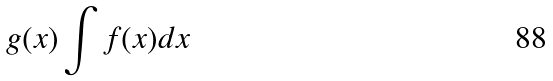Convert formula to latex. <formula><loc_0><loc_0><loc_500><loc_500>g ( x ) \int f ( x ) d x</formula> 